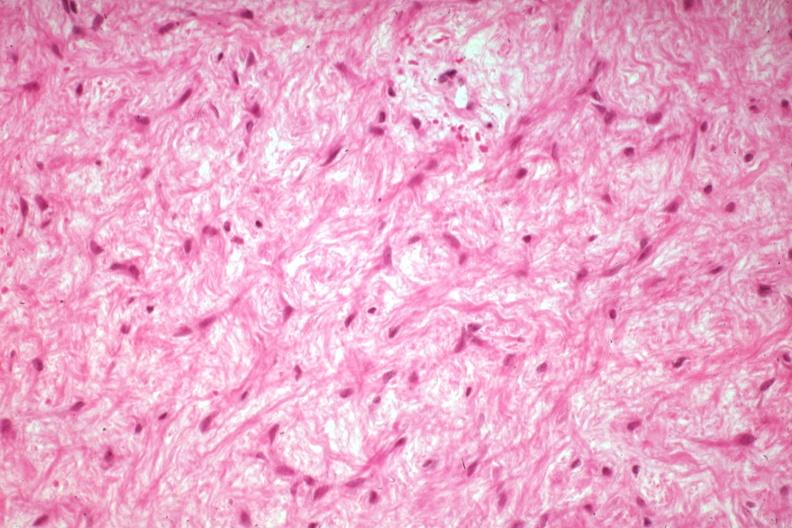what does this image show?
Answer the question using a single word or phrase. High excessive fibrous callus in a non-union excellent granulation type tissue with collagen 